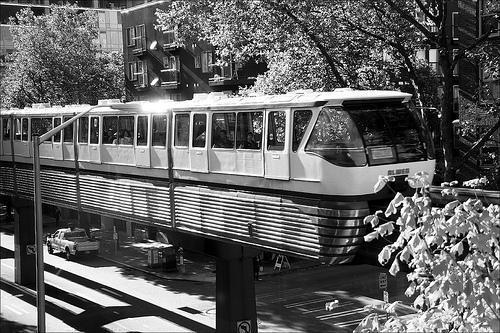How many trains?
Give a very brief answer. 1. 